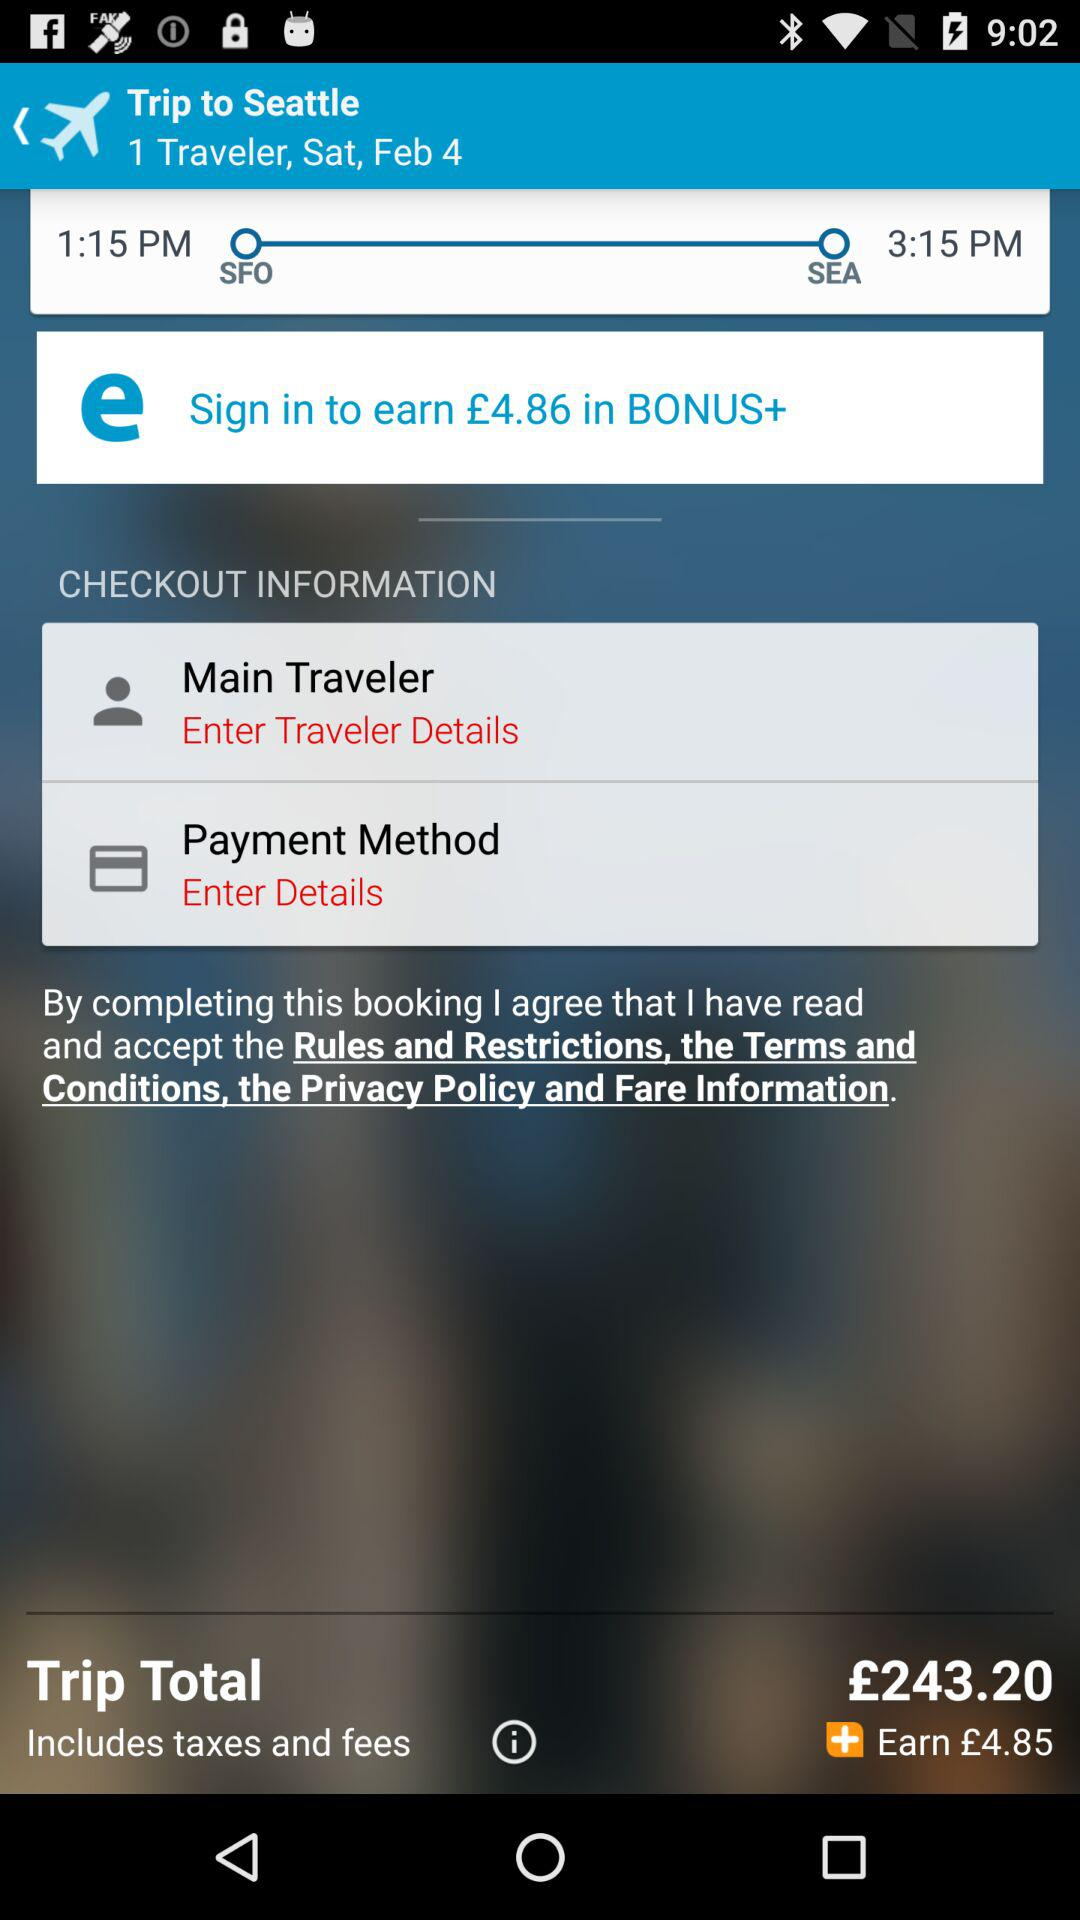What is the departure time? The departure time is 3:15 PM. 